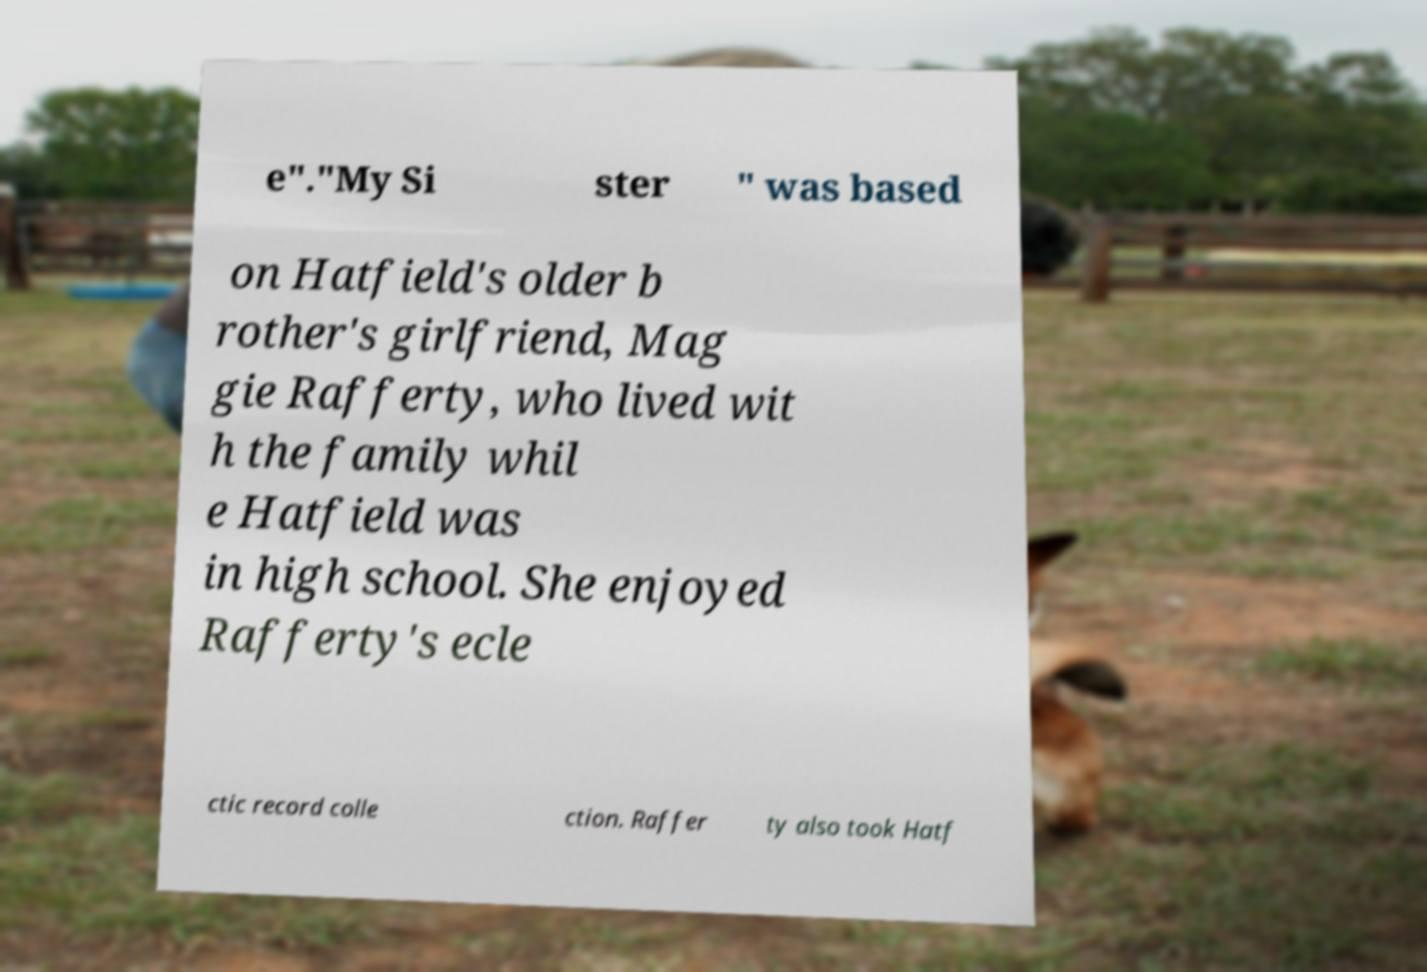Please identify and transcribe the text found in this image. e"."My Si ster " was based on Hatfield's older b rother's girlfriend, Mag gie Rafferty, who lived wit h the family whil e Hatfield was in high school. She enjoyed Rafferty's ecle ctic record colle ction. Raffer ty also took Hatf 